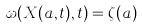Convert formula to latex. <formula><loc_0><loc_0><loc_500><loc_500>\omega ( X ( a , t ) , t ) = \zeta ( a )</formula> 